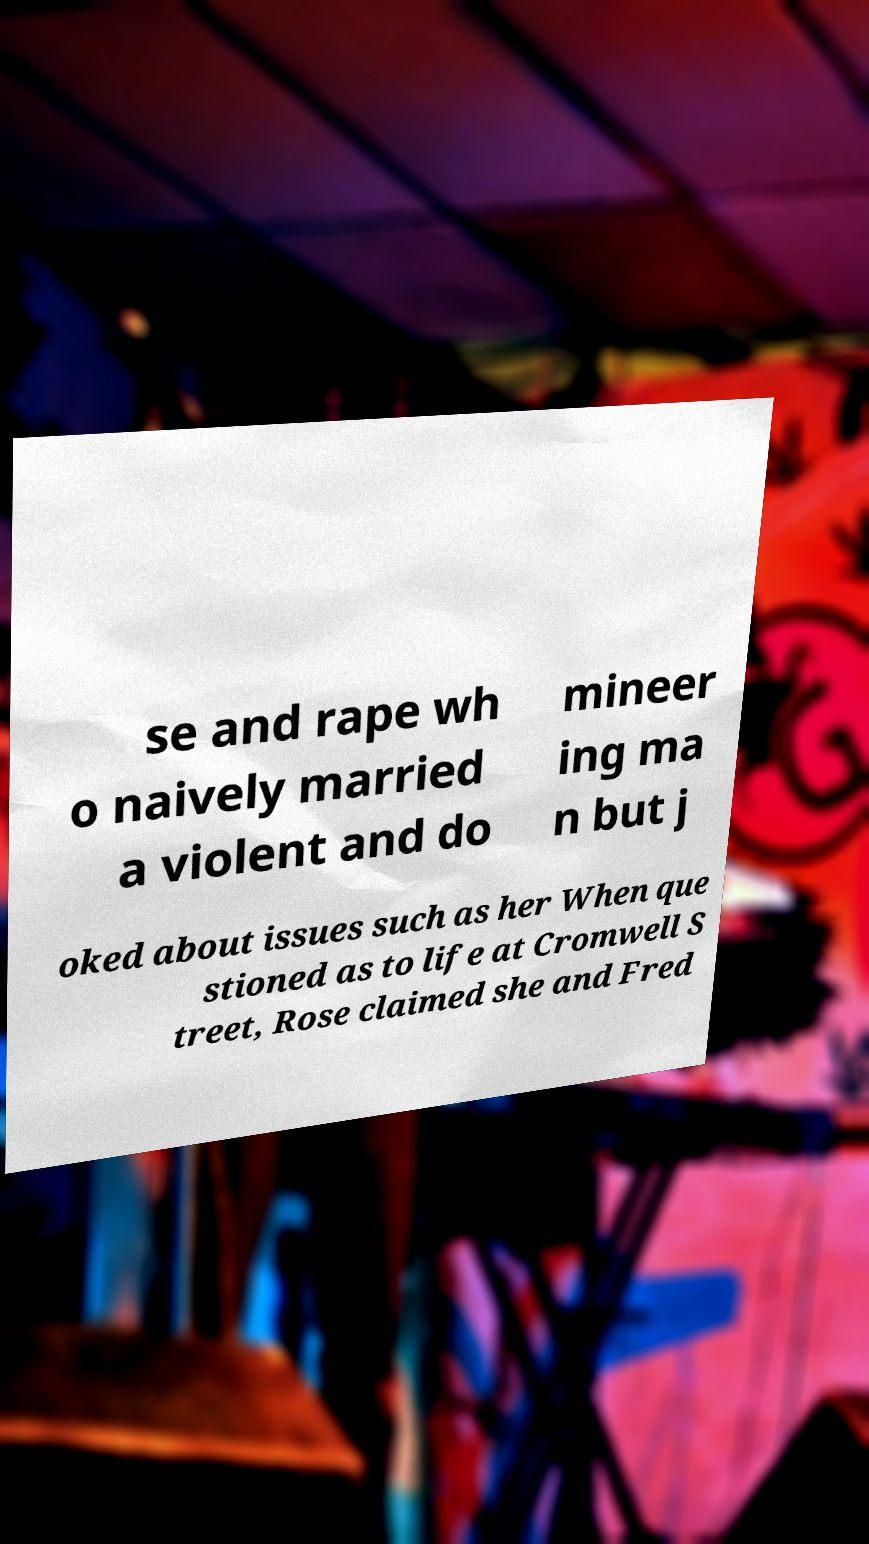Please identify and transcribe the text found in this image. se and rape wh o naively married a violent and do mineer ing ma n but j oked about issues such as her When que stioned as to life at Cromwell S treet, Rose claimed she and Fred 